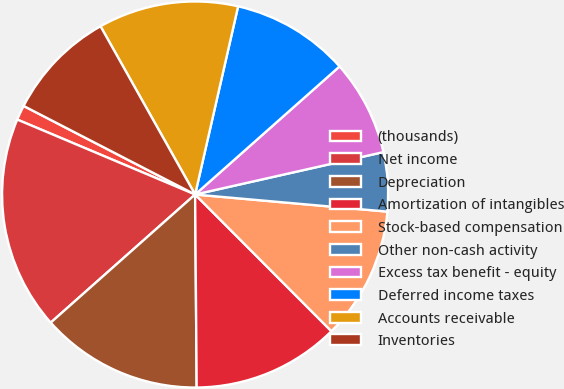<chart> <loc_0><loc_0><loc_500><loc_500><pie_chart><fcel>(thousands)<fcel>Net income<fcel>Depreciation<fcel>Amortization of intangibles<fcel>Stock-based compensation<fcel>Other non-cash activity<fcel>Excess tax benefit - equity<fcel>Deferred income taxes<fcel>Accounts receivable<fcel>Inventories<nl><fcel>1.24%<fcel>17.9%<fcel>13.58%<fcel>12.35%<fcel>11.11%<fcel>4.94%<fcel>8.02%<fcel>9.88%<fcel>11.73%<fcel>9.26%<nl></chart> 